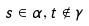Convert formula to latex. <formula><loc_0><loc_0><loc_500><loc_500>s \in \alpha , t \notin \gamma</formula> 